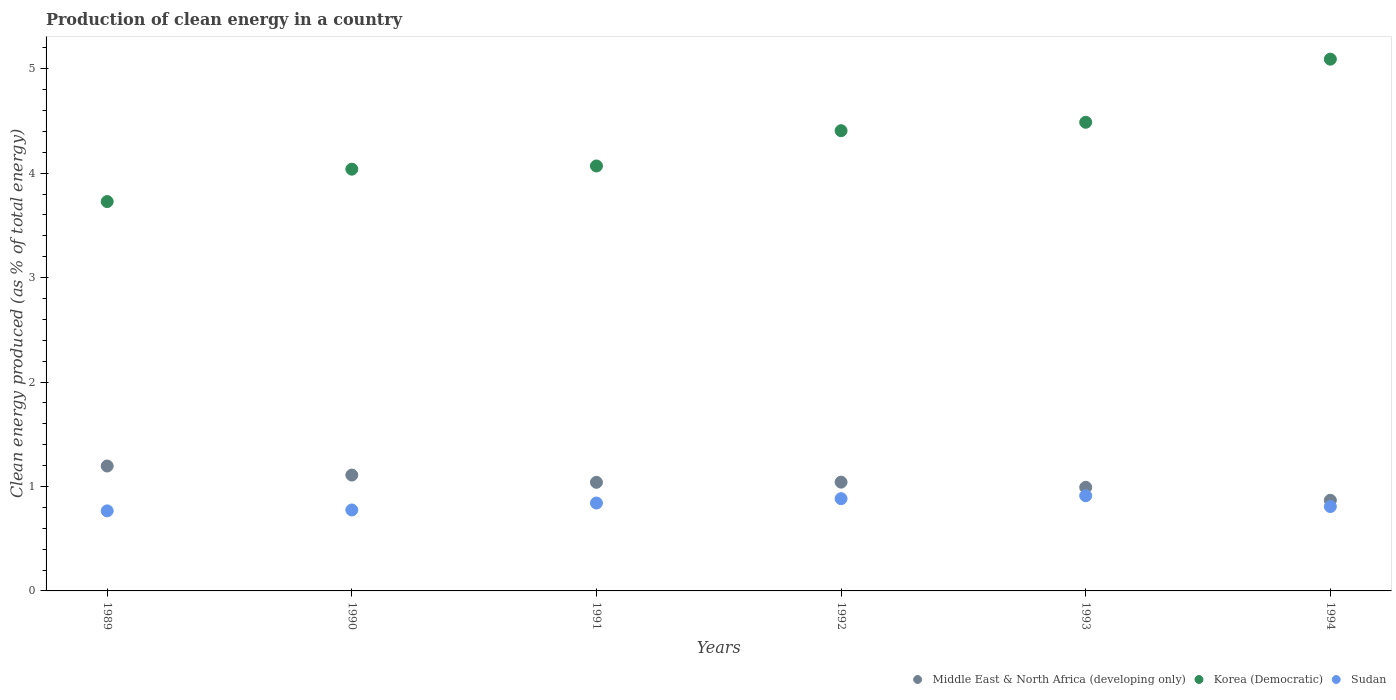How many different coloured dotlines are there?
Offer a very short reply. 3. Is the number of dotlines equal to the number of legend labels?
Provide a short and direct response. Yes. What is the percentage of clean energy produced in Korea (Democratic) in 1991?
Your answer should be compact. 4.07. Across all years, what is the maximum percentage of clean energy produced in Korea (Democratic)?
Your response must be concise. 5.09. Across all years, what is the minimum percentage of clean energy produced in Korea (Democratic)?
Make the answer very short. 3.73. In which year was the percentage of clean energy produced in Middle East & North Africa (developing only) minimum?
Give a very brief answer. 1994. What is the total percentage of clean energy produced in Korea (Democratic) in the graph?
Give a very brief answer. 25.82. What is the difference between the percentage of clean energy produced in Korea (Democratic) in 1993 and that in 1994?
Your response must be concise. -0.6. What is the difference between the percentage of clean energy produced in Sudan in 1994 and the percentage of clean energy produced in Middle East & North Africa (developing only) in 1990?
Provide a short and direct response. -0.3. What is the average percentage of clean energy produced in Sudan per year?
Make the answer very short. 0.83. In the year 1989, what is the difference between the percentage of clean energy produced in Middle East & North Africa (developing only) and percentage of clean energy produced in Korea (Democratic)?
Keep it short and to the point. -2.53. In how many years, is the percentage of clean energy produced in Korea (Democratic) greater than 3.8 %?
Give a very brief answer. 5. What is the ratio of the percentage of clean energy produced in Sudan in 1991 to that in 1993?
Provide a succinct answer. 0.92. Is the percentage of clean energy produced in Middle East & North Africa (developing only) in 1989 less than that in 1990?
Provide a short and direct response. No. Is the difference between the percentage of clean energy produced in Middle East & North Africa (developing only) in 1991 and 1994 greater than the difference between the percentage of clean energy produced in Korea (Democratic) in 1991 and 1994?
Ensure brevity in your answer.  Yes. What is the difference between the highest and the second highest percentage of clean energy produced in Middle East & North Africa (developing only)?
Ensure brevity in your answer.  0.09. What is the difference between the highest and the lowest percentage of clean energy produced in Middle East & North Africa (developing only)?
Provide a succinct answer. 0.33. Does the percentage of clean energy produced in Korea (Democratic) monotonically increase over the years?
Offer a very short reply. Yes. Is the percentage of clean energy produced in Sudan strictly greater than the percentage of clean energy produced in Korea (Democratic) over the years?
Your answer should be very brief. No. Is the percentage of clean energy produced in Korea (Democratic) strictly less than the percentage of clean energy produced in Sudan over the years?
Give a very brief answer. No. How many years are there in the graph?
Offer a terse response. 6. What is the difference between two consecutive major ticks on the Y-axis?
Offer a very short reply. 1. Does the graph contain any zero values?
Your answer should be very brief. No. How many legend labels are there?
Make the answer very short. 3. What is the title of the graph?
Keep it short and to the point. Production of clean energy in a country. What is the label or title of the X-axis?
Give a very brief answer. Years. What is the label or title of the Y-axis?
Offer a terse response. Clean energy produced (as % of total energy). What is the Clean energy produced (as % of total energy) in Middle East & North Africa (developing only) in 1989?
Your answer should be compact. 1.2. What is the Clean energy produced (as % of total energy) in Korea (Democratic) in 1989?
Your response must be concise. 3.73. What is the Clean energy produced (as % of total energy) in Sudan in 1989?
Provide a short and direct response. 0.77. What is the Clean energy produced (as % of total energy) of Middle East & North Africa (developing only) in 1990?
Provide a short and direct response. 1.11. What is the Clean energy produced (as % of total energy) of Korea (Democratic) in 1990?
Keep it short and to the point. 4.04. What is the Clean energy produced (as % of total energy) in Sudan in 1990?
Offer a terse response. 0.78. What is the Clean energy produced (as % of total energy) of Middle East & North Africa (developing only) in 1991?
Offer a very short reply. 1.04. What is the Clean energy produced (as % of total energy) in Korea (Democratic) in 1991?
Offer a terse response. 4.07. What is the Clean energy produced (as % of total energy) of Sudan in 1991?
Your answer should be compact. 0.84. What is the Clean energy produced (as % of total energy) in Middle East & North Africa (developing only) in 1992?
Your answer should be very brief. 1.04. What is the Clean energy produced (as % of total energy) of Korea (Democratic) in 1992?
Your answer should be compact. 4.41. What is the Clean energy produced (as % of total energy) of Sudan in 1992?
Offer a very short reply. 0.88. What is the Clean energy produced (as % of total energy) of Middle East & North Africa (developing only) in 1993?
Your answer should be very brief. 0.99. What is the Clean energy produced (as % of total energy) of Korea (Democratic) in 1993?
Your answer should be compact. 4.49. What is the Clean energy produced (as % of total energy) in Sudan in 1993?
Give a very brief answer. 0.91. What is the Clean energy produced (as % of total energy) of Middle East & North Africa (developing only) in 1994?
Give a very brief answer. 0.87. What is the Clean energy produced (as % of total energy) of Korea (Democratic) in 1994?
Offer a very short reply. 5.09. What is the Clean energy produced (as % of total energy) of Sudan in 1994?
Your response must be concise. 0.81. Across all years, what is the maximum Clean energy produced (as % of total energy) in Middle East & North Africa (developing only)?
Your answer should be very brief. 1.2. Across all years, what is the maximum Clean energy produced (as % of total energy) of Korea (Democratic)?
Your answer should be compact. 5.09. Across all years, what is the maximum Clean energy produced (as % of total energy) of Sudan?
Offer a very short reply. 0.91. Across all years, what is the minimum Clean energy produced (as % of total energy) of Middle East & North Africa (developing only)?
Give a very brief answer. 0.87. Across all years, what is the minimum Clean energy produced (as % of total energy) of Korea (Democratic)?
Keep it short and to the point. 3.73. Across all years, what is the minimum Clean energy produced (as % of total energy) of Sudan?
Keep it short and to the point. 0.77. What is the total Clean energy produced (as % of total energy) in Middle East & North Africa (developing only) in the graph?
Your answer should be very brief. 6.25. What is the total Clean energy produced (as % of total energy) of Korea (Democratic) in the graph?
Make the answer very short. 25.82. What is the total Clean energy produced (as % of total energy) of Sudan in the graph?
Your answer should be very brief. 4.99. What is the difference between the Clean energy produced (as % of total energy) of Middle East & North Africa (developing only) in 1989 and that in 1990?
Give a very brief answer. 0.09. What is the difference between the Clean energy produced (as % of total energy) in Korea (Democratic) in 1989 and that in 1990?
Your answer should be compact. -0.31. What is the difference between the Clean energy produced (as % of total energy) in Sudan in 1989 and that in 1990?
Your response must be concise. -0.01. What is the difference between the Clean energy produced (as % of total energy) in Middle East & North Africa (developing only) in 1989 and that in 1991?
Give a very brief answer. 0.16. What is the difference between the Clean energy produced (as % of total energy) of Korea (Democratic) in 1989 and that in 1991?
Your response must be concise. -0.34. What is the difference between the Clean energy produced (as % of total energy) in Sudan in 1989 and that in 1991?
Provide a short and direct response. -0.07. What is the difference between the Clean energy produced (as % of total energy) in Middle East & North Africa (developing only) in 1989 and that in 1992?
Keep it short and to the point. 0.15. What is the difference between the Clean energy produced (as % of total energy) of Korea (Democratic) in 1989 and that in 1992?
Your response must be concise. -0.68. What is the difference between the Clean energy produced (as % of total energy) of Sudan in 1989 and that in 1992?
Your answer should be very brief. -0.12. What is the difference between the Clean energy produced (as % of total energy) in Middle East & North Africa (developing only) in 1989 and that in 1993?
Offer a terse response. 0.2. What is the difference between the Clean energy produced (as % of total energy) of Korea (Democratic) in 1989 and that in 1993?
Ensure brevity in your answer.  -0.76. What is the difference between the Clean energy produced (as % of total energy) of Sudan in 1989 and that in 1993?
Your response must be concise. -0.14. What is the difference between the Clean energy produced (as % of total energy) of Middle East & North Africa (developing only) in 1989 and that in 1994?
Give a very brief answer. 0.33. What is the difference between the Clean energy produced (as % of total energy) in Korea (Democratic) in 1989 and that in 1994?
Keep it short and to the point. -1.36. What is the difference between the Clean energy produced (as % of total energy) of Sudan in 1989 and that in 1994?
Provide a short and direct response. -0.04. What is the difference between the Clean energy produced (as % of total energy) in Middle East & North Africa (developing only) in 1990 and that in 1991?
Provide a short and direct response. 0.07. What is the difference between the Clean energy produced (as % of total energy) of Korea (Democratic) in 1990 and that in 1991?
Offer a very short reply. -0.03. What is the difference between the Clean energy produced (as % of total energy) of Sudan in 1990 and that in 1991?
Your answer should be compact. -0.07. What is the difference between the Clean energy produced (as % of total energy) of Middle East & North Africa (developing only) in 1990 and that in 1992?
Your answer should be very brief. 0.07. What is the difference between the Clean energy produced (as % of total energy) of Korea (Democratic) in 1990 and that in 1992?
Ensure brevity in your answer.  -0.37. What is the difference between the Clean energy produced (as % of total energy) in Sudan in 1990 and that in 1992?
Keep it short and to the point. -0.11. What is the difference between the Clean energy produced (as % of total energy) of Middle East & North Africa (developing only) in 1990 and that in 1993?
Your response must be concise. 0.12. What is the difference between the Clean energy produced (as % of total energy) of Korea (Democratic) in 1990 and that in 1993?
Provide a succinct answer. -0.45. What is the difference between the Clean energy produced (as % of total energy) of Sudan in 1990 and that in 1993?
Your response must be concise. -0.14. What is the difference between the Clean energy produced (as % of total energy) in Middle East & North Africa (developing only) in 1990 and that in 1994?
Your answer should be very brief. 0.24. What is the difference between the Clean energy produced (as % of total energy) in Korea (Democratic) in 1990 and that in 1994?
Keep it short and to the point. -1.05. What is the difference between the Clean energy produced (as % of total energy) in Sudan in 1990 and that in 1994?
Give a very brief answer. -0.03. What is the difference between the Clean energy produced (as % of total energy) of Middle East & North Africa (developing only) in 1991 and that in 1992?
Ensure brevity in your answer.  -0. What is the difference between the Clean energy produced (as % of total energy) in Korea (Democratic) in 1991 and that in 1992?
Keep it short and to the point. -0.34. What is the difference between the Clean energy produced (as % of total energy) in Sudan in 1991 and that in 1992?
Keep it short and to the point. -0.04. What is the difference between the Clean energy produced (as % of total energy) in Middle East & North Africa (developing only) in 1991 and that in 1993?
Ensure brevity in your answer.  0.05. What is the difference between the Clean energy produced (as % of total energy) of Korea (Democratic) in 1991 and that in 1993?
Provide a short and direct response. -0.42. What is the difference between the Clean energy produced (as % of total energy) in Sudan in 1991 and that in 1993?
Your response must be concise. -0.07. What is the difference between the Clean energy produced (as % of total energy) in Middle East & North Africa (developing only) in 1991 and that in 1994?
Make the answer very short. 0.17. What is the difference between the Clean energy produced (as % of total energy) in Korea (Democratic) in 1991 and that in 1994?
Make the answer very short. -1.02. What is the difference between the Clean energy produced (as % of total energy) of Sudan in 1991 and that in 1994?
Your response must be concise. 0.03. What is the difference between the Clean energy produced (as % of total energy) in Middle East & North Africa (developing only) in 1992 and that in 1993?
Your response must be concise. 0.05. What is the difference between the Clean energy produced (as % of total energy) in Korea (Democratic) in 1992 and that in 1993?
Provide a short and direct response. -0.08. What is the difference between the Clean energy produced (as % of total energy) in Sudan in 1992 and that in 1993?
Offer a very short reply. -0.03. What is the difference between the Clean energy produced (as % of total energy) of Middle East & North Africa (developing only) in 1992 and that in 1994?
Provide a succinct answer. 0.17. What is the difference between the Clean energy produced (as % of total energy) of Korea (Democratic) in 1992 and that in 1994?
Offer a very short reply. -0.69. What is the difference between the Clean energy produced (as % of total energy) of Sudan in 1992 and that in 1994?
Keep it short and to the point. 0.08. What is the difference between the Clean energy produced (as % of total energy) of Middle East & North Africa (developing only) in 1993 and that in 1994?
Offer a terse response. 0.12. What is the difference between the Clean energy produced (as % of total energy) of Korea (Democratic) in 1993 and that in 1994?
Provide a succinct answer. -0.6. What is the difference between the Clean energy produced (as % of total energy) in Sudan in 1993 and that in 1994?
Give a very brief answer. 0.1. What is the difference between the Clean energy produced (as % of total energy) in Middle East & North Africa (developing only) in 1989 and the Clean energy produced (as % of total energy) in Korea (Democratic) in 1990?
Keep it short and to the point. -2.84. What is the difference between the Clean energy produced (as % of total energy) in Middle East & North Africa (developing only) in 1989 and the Clean energy produced (as % of total energy) in Sudan in 1990?
Your answer should be compact. 0.42. What is the difference between the Clean energy produced (as % of total energy) of Korea (Democratic) in 1989 and the Clean energy produced (as % of total energy) of Sudan in 1990?
Offer a terse response. 2.95. What is the difference between the Clean energy produced (as % of total energy) in Middle East & North Africa (developing only) in 1989 and the Clean energy produced (as % of total energy) in Korea (Democratic) in 1991?
Your answer should be compact. -2.87. What is the difference between the Clean energy produced (as % of total energy) of Middle East & North Africa (developing only) in 1989 and the Clean energy produced (as % of total energy) of Sudan in 1991?
Give a very brief answer. 0.35. What is the difference between the Clean energy produced (as % of total energy) of Korea (Democratic) in 1989 and the Clean energy produced (as % of total energy) of Sudan in 1991?
Offer a terse response. 2.89. What is the difference between the Clean energy produced (as % of total energy) in Middle East & North Africa (developing only) in 1989 and the Clean energy produced (as % of total energy) in Korea (Democratic) in 1992?
Make the answer very short. -3.21. What is the difference between the Clean energy produced (as % of total energy) in Middle East & North Africa (developing only) in 1989 and the Clean energy produced (as % of total energy) in Sudan in 1992?
Keep it short and to the point. 0.31. What is the difference between the Clean energy produced (as % of total energy) in Korea (Democratic) in 1989 and the Clean energy produced (as % of total energy) in Sudan in 1992?
Provide a short and direct response. 2.84. What is the difference between the Clean energy produced (as % of total energy) of Middle East & North Africa (developing only) in 1989 and the Clean energy produced (as % of total energy) of Korea (Democratic) in 1993?
Offer a terse response. -3.29. What is the difference between the Clean energy produced (as % of total energy) in Middle East & North Africa (developing only) in 1989 and the Clean energy produced (as % of total energy) in Sudan in 1993?
Ensure brevity in your answer.  0.28. What is the difference between the Clean energy produced (as % of total energy) of Korea (Democratic) in 1989 and the Clean energy produced (as % of total energy) of Sudan in 1993?
Provide a succinct answer. 2.82. What is the difference between the Clean energy produced (as % of total energy) of Middle East & North Africa (developing only) in 1989 and the Clean energy produced (as % of total energy) of Korea (Democratic) in 1994?
Offer a terse response. -3.9. What is the difference between the Clean energy produced (as % of total energy) of Middle East & North Africa (developing only) in 1989 and the Clean energy produced (as % of total energy) of Sudan in 1994?
Give a very brief answer. 0.39. What is the difference between the Clean energy produced (as % of total energy) of Korea (Democratic) in 1989 and the Clean energy produced (as % of total energy) of Sudan in 1994?
Make the answer very short. 2.92. What is the difference between the Clean energy produced (as % of total energy) of Middle East & North Africa (developing only) in 1990 and the Clean energy produced (as % of total energy) of Korea (Democratic) in 1991?
Provide a succinct answer. -2.96. What is the difference between the Clean energy produced (as % of total energy) in Middle East & North Africa (developing only) in 1990 and the Clean energy produced (as % of total energy) in Sudan in 1991?
Ensure brevity in your answer.  0.27. What is the difference between the Clean energy produced (as % of total energy) of Korea (Democratic) in 1990 and the Clean energy produced (as % of total energy) of Sudan in 1991?
Give a very brief answer. 3.2. What is the difference between the Clean energy produced (as % of total energy) in Middle East & North Africa (developing only) in 1990 and the Clean energy produced (as % of total energy) in Korea (Democratic) in 1992?
Offer a very short reply. -3.3. What is the difference between the Clean energy produced (as % of total energy) of Middle East & North Africa (developing only) in 1990 and the Clean energy produced (as % of total energy) of Sudan in 1992?
Provide a succinct answer. 0.23. What is the difference between the Clean energy produced (as % of total energy) in Korea (Democratic) in 1990 and the Clean energy produced (as % of total energy) in Sudan in 1992?
Provide a short and direct response. 3.15. What is the difference between the Clean energy produced (as % of total energy) in Middle East & North Africa (developing only) in 1990 and the Clean energy produced (as % of total energy) in Korea (Democratic) in 1993?
Ensure brevity in your answer.  -3.38. What is the difference between the Clean energy produced (as % of total energy) of Middle East & North Africa (developing only) in 1990 and the Clean energy produced (as % of total energy) of Sudan in 1993?
Provide a short and direct response. 0.2. What is the difference between the Clean energy produced (as % of total energy) of Korea (Democratic) in 1990 and the Clean energy produced (as % of total energy) of Sudan in 1993?
Your answer should be compact. 3.13. What is the difference between the Clean energy produced (as % of total energy) of Middle East & North Africa (developing only) in 1990 and the Clean energy produced (as % of total energy) of Korea (Democratic) in 1994?
Your response must be concise. -3.98. What is the difference between the Clean energy produced (as % of total energy) of Middle East & North Africa (developing only) in 1990 and the Clean energy produced (as % of total energy) of Sudan in 1994?
Keep it short and to the point. 0.3. What is the difference between the Clean energy produced (as % of total energy) of Korea (Democratic) in 1990 and the Clean energy produced (as % of total energy) of Sudan in 1994?
Keep it short and to the point. 3.23. What is the difference between the Clean energy produced (as % of total energy) in Middle East & North Africa (developing only) in 1991 and the Clean energy produced (as % of total energy) in Korea (Democratic) in 1992?
Ensure brevity in your answer.  -3.37. What is the difference between the Clean energy produced (as % of total energy) in Middle East & North Africa (developing only) in 1991 and the Clean energy produced (as % of total energy) in Sudan in 1992?
Give a very brief answer. 0.16. What is the difference between the Clean energy produced (as % of total energy) in Korea (Democratic) in 1991 and the Clean energy produced (as % of total energy) in Sudan in 1992?
Provide a succinct answer. 3.19. What is the difference between the Clean energy produced (as % of total energy) in Middle East & North Africa (developing only) in 1991 and the Clean energy produced (as % of total energy) in Korea (Democratic) in 1993?
Give a very brief answer. -3.45. What is the difference between the Clean energy produced (as % of total energy) of Middle East & North Africa (developing only) in 1991 and the Clean energy produced (as % of total energy) of Sudan in 1993?
Make the answer very short. 0.13. What is the difference between the Clean energy produced (as % of total energy) in Korea (Democratic) in 1991 and the Clean energy produced (as % of total energy) in Sudan in 1993?
Your answer should be compact. 3.16. What is the difference between the Clean energy produced (as % of total energy) in Middle East & North Africa (developing only) in 1991 and the Clean energy produced (as % of total energy) in Korea (Democratic) in 1994?
Your answer should be very brief. -4.05. What is the difference between the Clean energy produced (as % of total energy) of Middle East & North Africa (developing only) in 1991 and the Clean energy produced (as % of total energy) of Sudan in 1994?
Offer a very short reply. 0.23. What is the difference between the Clean energy produced (as % of total energy) in Korea (Democratic) in 1991 and the Clean energy produced (as % of total energy) in Sudan in 1994?
Make the answer very short. 3.26. What is the difference between the Clean energy produced (as % of total energy) in Middle East & North Africa (developing only) in 1992 and the Clean energy produced (as % of total energy) in Korea (Democratic) in 1993?
Your answer should be compact. -3.45. What is the difference between the Clean energy produced (as % of total energy) of Middle East & North Africa (developing only) in 1992 and the Clean energy produced (as % of total energy) of Sudan in 1993?
Give a very brief answer. 0.13. What is the difference between the Clean energy produced (as % of total energy) in Korea (Democratic) in 1992 and the Clean energy produced (as % of total energy) in Sudan in 1993?
Offer a terse response. 3.5. What is the difference between the Clean energy produced (as % of total energy) in Middle East & North Africa (developing only) in 1992 and the Clean energy produced (as % of total energy) in Korea (Democratic) in 1994?
Your answer should be very brief. -4.05. What is the difference between the Clean energy produced (as % of total energy) in Middle East & North Africa (developing only) in 1992 and the Clean energy produced (as % of total energy) in Sudan in 1994?
Your answer should be very brief. 0.23. What is the difference between the Clean energy produced (as % of total energy) in Korea (Democratic) in 1992 and the Clean energy produced (as % of total energy) in Sudan in 1994?
Ensure brevity in your answer.  3.6. What is the difference between the Clean energy produced (as % of total energy) in Middle East & North Africa (developing only) in 1993 and the Clean energy produced (as % of total energy) in Korea (Democratic) in 1994?
Ensure brevity in your answer.  -4.1. What is the difference between the Clean energy produced (as % of total energy) of Middle East & North Africa (developing only) in 1993 and the Clean energy produced (as % of total energy) of Sudan in 1994?
Make the answer very short. 0.18. What is the difference between the Clean energy produced (as % of total energy) in Korea (Democratic) in 1993 and the Clean energy produced (as % of total energy) in Sudan in 1994?
Your response must be concise. 3.68. What is the average Clean energy produced (as % of total energy) of Middle East & North Africa (developing only) per year?
Give a very brief answer. 1.04. What is the average Clean energy produced (as % of total energy) of Korea (Democratic) per year?
Your answer should be compact. 4.3. What is the average Clean energy produced (as % of total energy) in Sudan per year?
Provide a short and direct response. 0.83. In the year 1989, what is the difference between the Clean energy produced (as % of total energy) of Middle East & North Africa (developing only) and Clean energy produced (as % of total energy) of Korea (Democratic)?
Give a very brief answer. -2.53. In the year 1989, what is the difference between the Clean energy produced (as % of total energy) of Middle East & North Africa (developing only) and Clean energy produced (as % of total energy) of Sudan?
Your answer should be very brief. 0.43. In the year 1989, what is the difference between the Clean energy produced (as % of total energy) in Korea (Democratic) and Clean energy produced (as % of total energy) in Sudan?
Your response must be concise. 2.96. In the year 1990, what is the difference between the Clean energy produced (as % of total energy) of Middle East & North Africa (developing only) and Clean energy produced (as % of total energy) of Korea (Democratic)?
Offer a terse response. -2.93. In the year 1990, what is the difference between the Clean energy produced (as % of total energy) in Middle East & North Africa (developing only) and Clean energy produced (as % of total energy) in Sudan?
Your answer should be very brief. 0.33. In the year 1990, what is the difference between the Clean energy produced (as % of total energy) of Korea (Democratic) and Clean energy produced (as % of total energy) of Sudan?
Offer a very short reply. 3.26. In the year 1991, what is the difference between the Clean energy produced (as % of total energy) of Middle East & North Africa (developing only) and Clean energy produced (as % of total energy) of Korea (Democratic)?
Ensure brevity in your answer.  -3.03. In the year 1991, what is the difference between the Clean energy produced (as % of total energy) in Middle East & North Africa (developing only) and Clean energy produced (as % of total energy) in Sudan?
Make the answer very short. 0.2. In the year 1991, what is the difference between the Clean energy produced (as % of total energy) in Korea (Democratic) and Clean energy produced (as % of total energy) in Sudan?
Offer a terse response. 3.23. In the year 1992, what is the difference between the Clean energy produced (as % of total energy) in Middle East & North Africa (developing only) and Clean energy produced (as % of total energy) in Korea (Democratic)?
Your response must be concise. -3.37. In the year 1992, what is the difference between the Clean energy produced (as % of total energy) of Middle East & North Africa (developing only) and Clean energy produced (as % of total energy) of Sudan?
Give a very brief answer. 0.16. In the year 1992, what is the difference between the Clean energy produced (as % of total energy) of Korea (Democratic) and Clean energy produced (as % of total energy) of Sudan?
Provide a short and direct response. 3.52. In the year 1993, what is the difference between the Clean energy produced (as % of total energy) of Middle East & North Africa (developing only) and Clean energy produced (as % of total energy) of Korea (Democratic)?
Your answer should be compact. -3.5. In the year 1993, what is the difference between the Clean energy produced (as % of total energy) of Middle East & North Africa (developing only) and Clean energy produced (as % of total energy) of Sudan?
Your answer should be very brief. 0.08. In the year 1993, what is the difference between the Clean energy produced (as % of total energy) in Korea (Democratic) and Clean energy produced (as % of total energy) in Sudan?
Provide a short and direct response. 3.58. In the year 1994, what is the difference between the Clean energy produced (as % of total energy) in Middle East & North Africa (developing only) and Clean energy produced (as % of total energy) in Korea (Democratic)?
Provide a short and direct response. -4.22. In the year 1994, what is the difference between the Clean energy produced (as % of total energy) of Korea (Democratic) and Clean energy produced (as % of total energy) of Sudan?
Your answer should be very brief. 4.28. What is the ratio of the Clean energy produced (as % of total energy) of Middle East & North Africa (developing only) in 1989 to that in 1990?
Offer a terse response. 1.08. What is the ratio of the Clean energy produced (as % of total energy) in Korea (Democratic) in 1989 to that in 1990?
Your answer should be compact. 0.92. What is the ratio of the Clean energy produced (as % of total energy) in Middle East & North Africa (developing only) in 1989 to that in 1991?
Your response must be concise. 1.15. What is the ratio of the Clean energy produced (as % of total energy) of Korea (Democratic) in 1989 to that in 1991?
Your response must be concise. 0.92. What is the ratio of the Clean energy produced (as % of total energy) of Sudan in 1989 to that in 1991?
Your answer should be very brief. 0.91. What is the ratio of the Clean energy produced (as % of total energy) in Middle East & North Africa (developing only) in 1989 to that in 1992?
Give a very brief answer. 1.15. What is the ratio of the Clean energy produced (as % of total energy) of Korea (Democratic) in 1989 to that in 1992?
Provide a short and direct response. 0.85. What is the ratio of the Clean energy produced (as % of total energy) in Sudan in 1989 to that in 1992?
Your answer should be very brief. 0.87. What is the ratio of the Clean energy produced (as % of total energy) of Middle East & North Africa (developing only) in 1989 to that in 1993?
Make the answer very short. 1.21. What is the ratio of the Clean energy produced (as % of total energy) of Korea (Democratic) in 1989 to that in 1993?
Make the answer very short. 0.83. What is the ratio of the Clean energy produced (as % of total energy) of Sudan in 1989 to that in 1993?
Your answer should be very brief. 0.84. What is the ratio of the Clean energy produced (as % of total energy) of Middle East & North Africa (developing only) in 1989 to that in 1994?
Offer a very short reply. 1.38. What is the ratio of the Clean energy produced (as % of total energy) in Korea (Democratic) in 1989 to that in 1994?
Provide a succinct answer. 0.73. What is the ratio of the Clean energy produced (as % of total energy) in Sudan in 1989 to that in 1994?
Offer a terse response. 0.95. What is the ratio of the Clean energy produced (as % of total energy) of Middle East & North Africa (developing only) in 1990 to that in 1991?
Ensure brevity in your answer.  1.07. What is the ratio of the Clean energy produced (as % of total energy) of Sudan in 1990 to that in 1991?
Provide a succinct answer. 0.92. What is the ratio of the Clean energy produced (as % of total energy) of Middle East & North Africa (developing only) in 1990 to that in 1992?
Your answer should be compact. 1.07. What is the ratio of the Clean energy produced (as % of total energy) in Korea (Democratic) in 1990 to that in 1992?
Provide a short and direct response. 0.92. What is the ratio of the Clean energy produced (as % of total energy) of Sudan in 1990 to that in 1992?
Your answer should be very brief. 0.88. What is the ratio of the Clean energy produced (as % of total energy) of Middle East & North Africa (developing only) in 1990 to that in 1993?
Offer a very short reply. 1.12. What is the ratio of the Clean energy produced (as % of total energy) of Korea (Democratic) in 1990 to that in 1993?
Keep it short and to the point. 0.9. What is the ratio of the Clean energy produced (as % of total energy) in Sudan in 1990 to that in 1993?
Give a very brief answer. 0.85. What is the ratio of the Clean energy produced (as % of total energy) of Middle East & North Africa (developing only) in 1990 to that in 1994?
Make the answer very short. 1.28. What is the ratio of the Clean energy produced (as % of total energy) in Korea (Democratic) in 1990 to that in 1994?
Your response must be concise. 0.79. What is the ratio of the Clean energy produced (as % of total energy) of Sudan in 1990 to that in 1994?
Give a very brief answer. 0.96. What is the ratio of the Clean energy produced (as % of total energy) in Korea (Democratic) in 1991 to that in 1992?
Your answer should be compact. 0.92. What is the ratio of the Clean energy produced (as % of total energy) of Sudan in 1991 to that in 1992?
Your response must be concise. 0.95. What is the ratio of the Clean energy produced (as % of total energy) of Middle East & North Africa (developing only) in 1991 to that in 1993?
Offer a very short reply. 1.05. What is the ratio of the Clean energy produced (as % of total energy) of Korea (Democratic) in 1991 to that in 1993?
Offer a terse response. 0.91. What is the ratio of the Clean energy produced (as % of total energy) in Sudan in 1991 to that in 1993?
Give a very brief answer. 0.92. What is the ratio of the Clean energy produced (as % of total energy) in Middle East & North Africa (developing only) in 1991 to that in 1994?
Offer a terse response. 1.2. What is the ratio of the Clean energy produced (as % of total energy) in Korea (Democratic) in 1991 to that in 1994?
Offer a terse response. 0.8. What is the ratio of the Clean energy produced (as % of total energy) of Sudan in 1991 to that in 1994?
Offer a terse response. 1.04. What is the ratio of the Clean energy produced (as % of total energy) in Middle East & North Africa (developing only) in 1992 to that in 1993?
Keep it short and to the point. 1.05. What is the ratio of the Clean energy produced (as % of total energy) of Sudan in 1992 to that in 1993?
Your answer should be compact. 0.97. What is the ratio of the Clean energy produced (as % of total energy) of Middle East & North Africa (developing only) in 1992 to that in 1994?
Provide a succinct answer. 1.2. What is the ratio of the Clean energy produced (as % of total energy) in Korea (Democratic) in 1992 to that in 1994?
Your answer should be very brief. 0.87. What is the ratio of the Clean energy produced (as % of total energy) of Sudan in 1992 to that in 1994?
Make the answer very short. 1.09. What is the ratio of the Clean energy produced (as % of total energy) in Middle East & North Africa (developing only) in 1993 to that in 1994?
Offer a very short reply. 1.14. What is the ratio of the Clean energy produced (as % of total energy) of Korea (Democratic) in 1993 to that in 1994?
Offer a very short reply. 0.88. What is the ratio of the Clean energy produced (as % of total energy) in Sudan in 1993 to that in 1994?
Offer a very short reply. 1.13. What is the difference between the highest and the second highest Clean energy produced (as % of total energy) in Middle East & North Africa (developing only)?
Keep it short and to the point. 0.09. What is the difference between the highest and the second highest Clean energy produced (as % of total energy) of Korea (Democratic)?
Your answer should be compact. 0.6. What is the difference between the highest and the second highest Clean energy produced (as % of total energy) in Sudan?
Make the answer very short. 0.03. What is the difference between the highest and the lowest Clean energy produced (as % of total energy) in Middle East & North Africa (developing only)?
Ensure brevity in your answer.  0.33. What is the difference between the highest and the lowest Clean energy produced (as % of total energy) of Korea (Democratic)?
Give a very brief answer. 1.36. What is the difference between the highest and the lowest Clean energy produced (as % of total energy) in Sudan?
Ensure brevity in your answer.  0.14. 